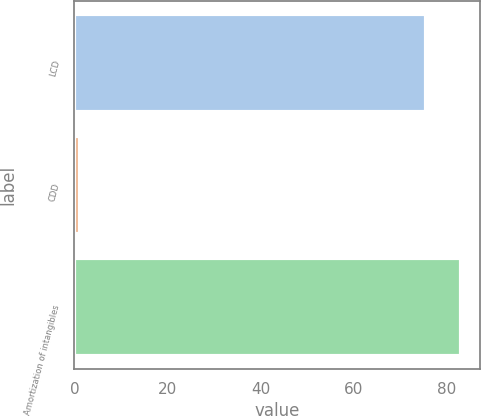Convert chart to OTSL. <chart><loc_0><loc_0><loc_500><loc_500><bar_chart><fcel>LCD<fcel>CDD<fcel>Amortization of intangibles<nl><fcel>75.5<fcel>1.2<fcel>83.05<nl></chart> 